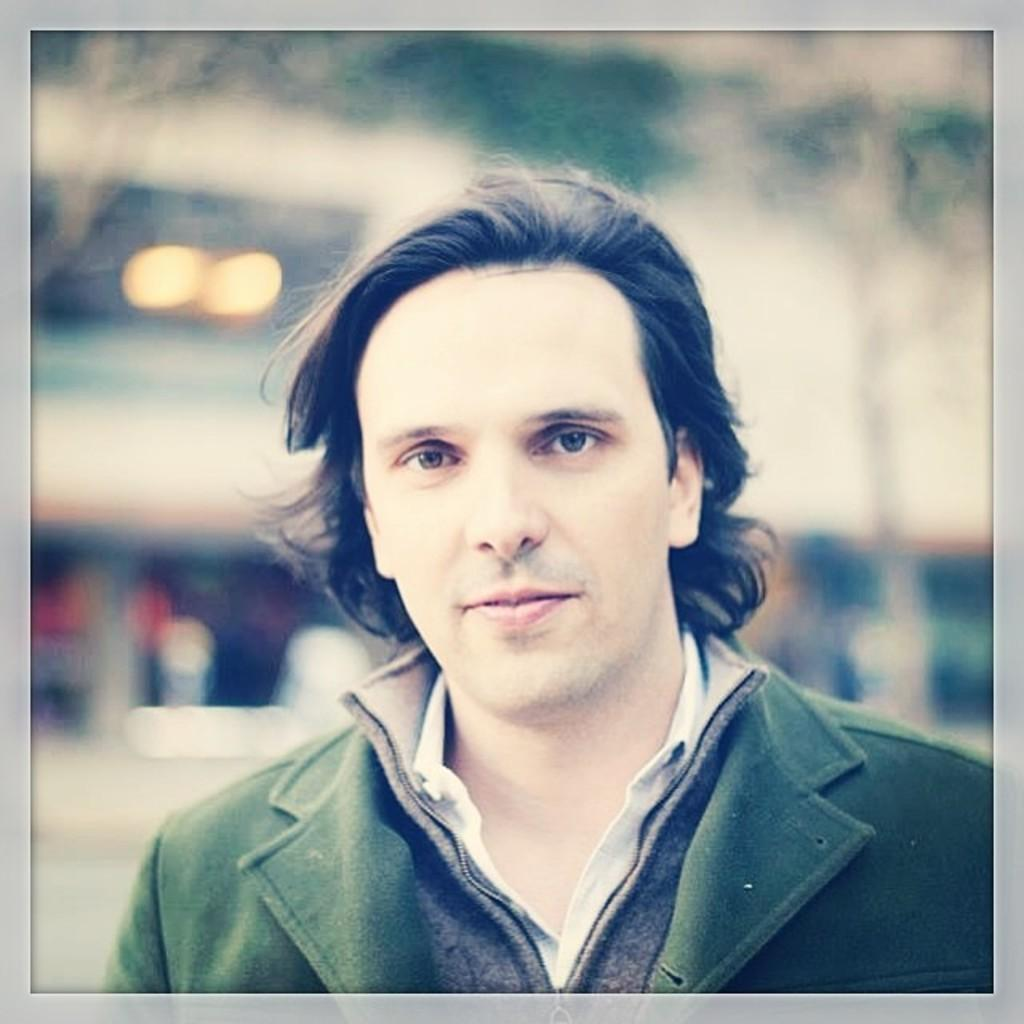What is the main subject of the image? There is a man in the image. How would you describe the background of the image? The background of the image is blurred. What color are the borders of the image? The borders of the image are ash-colored. How many feathers can be seen on the chair in the image? There is no chair present in the image, and therefore no feathers can be observed. 